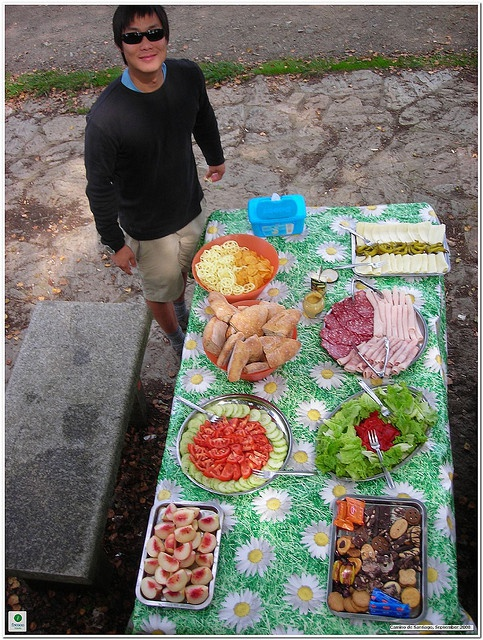Describe the objects in this image and their specific colors. I can see dining table in white, darkgray, lightgray, turquoise, and teal tones, people in white, black, gray, brown, and darkgray tones, bench in white, gray, and black tones, bowl in white, tan, and salmon tones, and bowl in white, khaki, tan, red, and salmon tones in this image. 